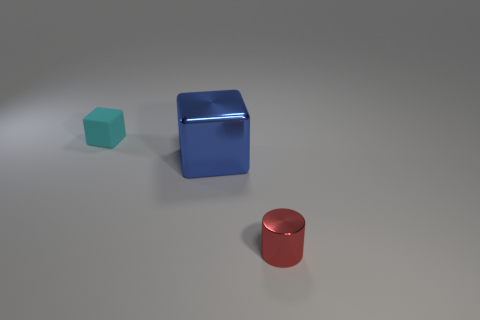What color is the tiny object that is on the right side of the small cyan thing?
Your response must be concise. Red. What material is the thing that is both behind the tiny red metallic thing and to the right of the tiny cyan cube?
Provide a short and direct response. Metal. What shape is the red object that is made of the same material as the large block?
Your answer should be very brief. Cylinder. There is a object behind the big blue metallic block; what number of small things are in front of it?
Provide a succinct answer. 1. What number of metallic things are both on the right side of the big blue shiny cube and on the left side of the small shiny cylinder?
Your response must be concise. 0. What number of other objects are the same material as the cyan block?
Provide a succinct answer. 0. What is the color of the tiny object in front of the small object that is on the left side of the red metallic cylinder?
Your answer should be compact. Red. Do the blue block and the cyan object have the same size?
Provide a succinct answer. No. The thing that is the same size as the cyan cube is what shape?
Provide a succinct answer. Cylinder. Do the cube in front of the cyan rubber block and the red shiny object have the same size?
Keep it short and to the point. No. 